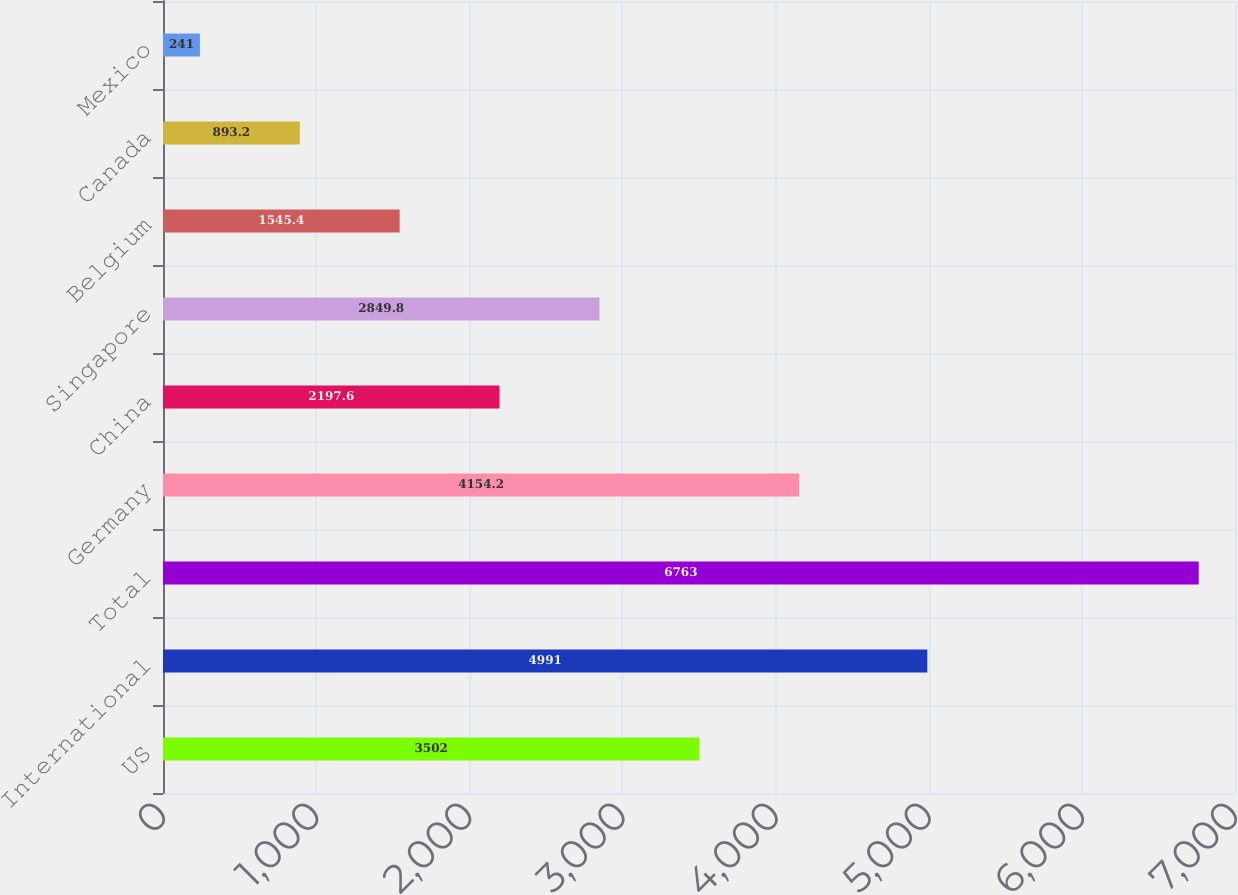Convert chart. <chart><loc_0><loc_0><loc_500><loc_500><bar_chart><fcel>US<fcel>International<fcel>Total<fcel>Germany<fcel>China<fcel>Singapore<fcel>Belgium<fcel>Canada<fcel>Mexico<nl><fcel>3502<fcel>4991<fcel>6763<fcel>4154.2<fcel>2197.6<fcel>2849.8<fcel>1545.4<fcel>893.2<fcel>241<nl></chart> 